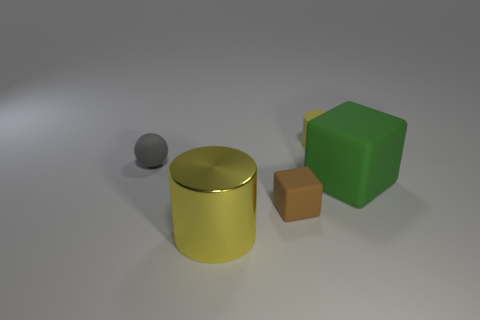Is there anything else that has the same material as the big cylinder?
Offer a terse response. No. There is a tiny ball; is its color the same as the large thing behind the large cylinder?
Offer a terse response. No. How many other objects are the same shape as the yellow metal thing?
Offer a terse response. 1. What is the cylinder that is in front of the gray rubber sphere made of?
Your response must be concise. Metal. There is a big thing that is behind the large yellow cylinder; is its shape the same as the small gray object?
Provide a succinct answer. No. Is there a green matte object that has the same size as the yellow metallic cylinder?
Make the answer very short. Yes. Does the tiny gray matte object have the same shape as the big object that is on the left side of the tiny brown rubber thing?
Make the answer very short. No. There is a large object that is the same color as the tiny cylinder; what shape is it?
Give a very brief answer. Cylinder. Are there fewer large matte cubes in front of the big green matte block than big purple cylinders?
Your response must be concise. No. Does the large green object have the same shape as the large yellow object?
Provide a short and direct response. No. 